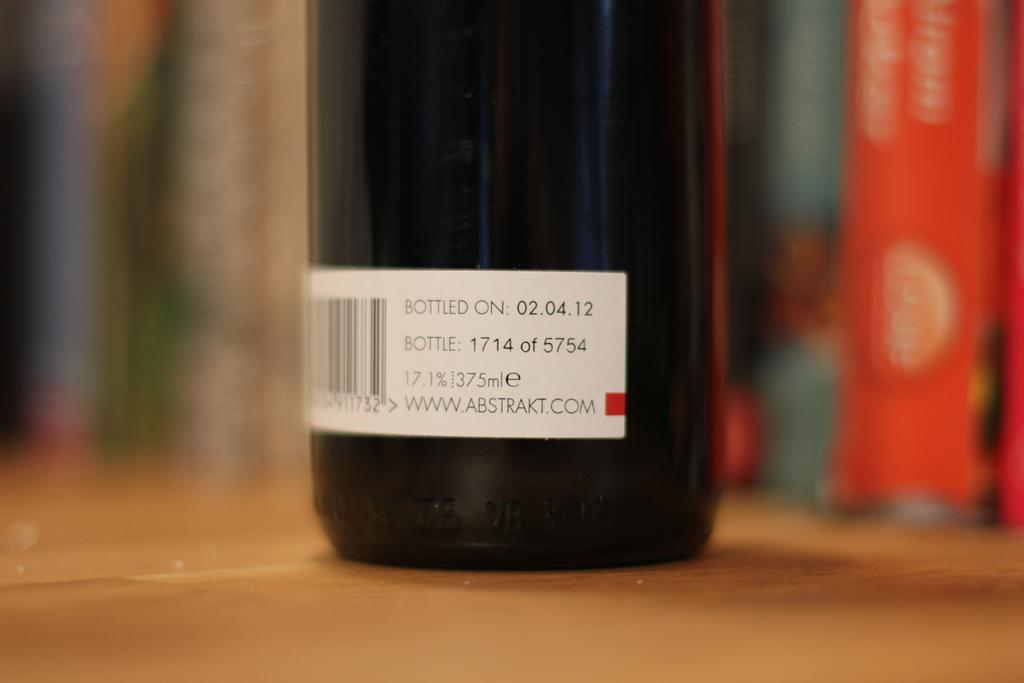<image>
Render a clear and concise summary of the photo. The label on a bottle states that it was bottled on "02.04.12." 